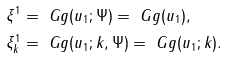<formula> <loc_0><loc_0><loc_500><loc_500>\xi ^ { 1 } & = \ G g ( u _ { 1 } ; \Psi ) = \ G g ( u _ { 1 } ) , \\ \xi ^ { 1 } _ { k } & = \ G g ( u _ { 1 } ; k , \Psi ) = \ G g ( u _ { 1 } ; k ) .</formula> 